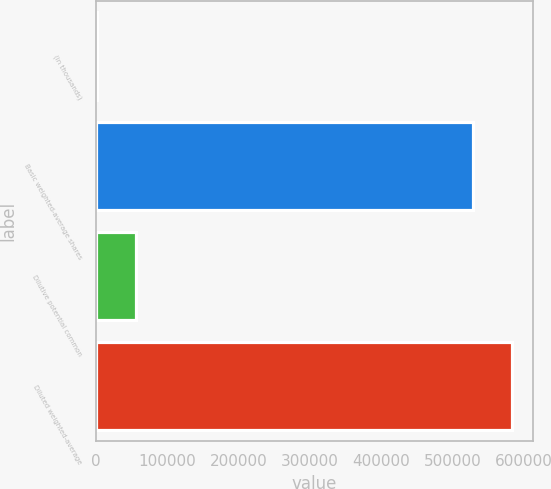Convert chart to OTSL. <chart><loc_0><loc_0><loc_500><loc_500><bar_chart><fcel>(in thousands)<fcel>Basic weighted-average shares<fcel>Dilutive potential common<fcel>Diluted weighted-average<nl><fcel>2016<fcel>529290<fcel>56061.7<fcel>583336<nl></chart> 